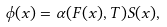Convert formula to latex. <formula><loc_0><loc_0><loc_500><loc_500>\phi ( x ) = \alpha ( F ( x ) , T ) S ( x ) ,</formula> 